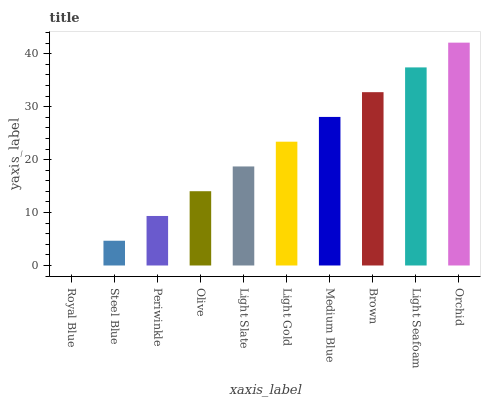Is Royal Blue the minimum?
Answer yes or no. Yes. Is Orchid the maximum?
Answer yes or no. Yes. Is Steel Blue the minimum?
Answer yes or no. No. Is Steel Blue the maximum?
Answer yes or no. No. Is Steel Blue greater than Royal Blue?
Answer yes or no. Yes. Is Royal Blue less than Steel Blue?
Answer yes or no. Yes. Is Royal Blue greater than Steel Blue?
Answer yes or no. No. Is Steel Blue less than Royal Blue?
Answer yes or no. No. Is Light Gold the high median?
Answer yes or no. Yes. Is Light Slate the low median?
Answer yes or no. Yes. Is Steel Blue the high median?
Answer yes or no. No. Is Steel Blue the low median?
Answer yes or no. No. 